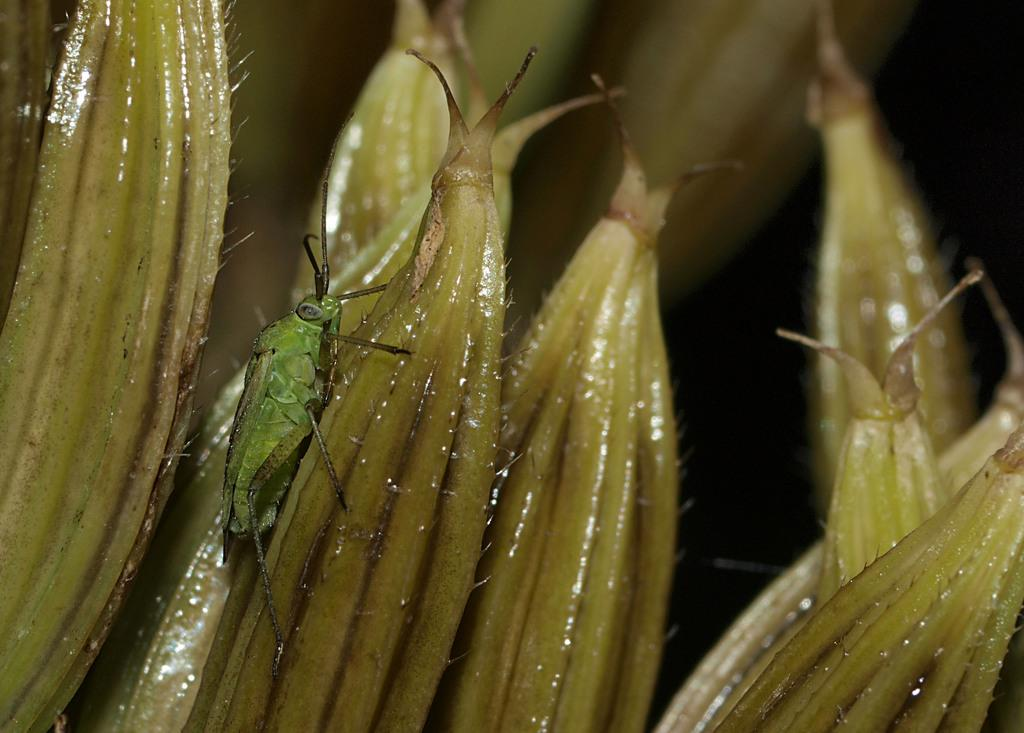What color are the shining objects in the image? The shining objects in the image are light green. What type of insect can be seen in the image? There is a grasshopper in the image. What type of soda is being advertised by the pig in the image? There is no pig or soda present in the image. What type of attraction is the grasshopper a part of in the image? The image does not depict any attractions or events; it simply shows a grasshopper and light green shining objects. 